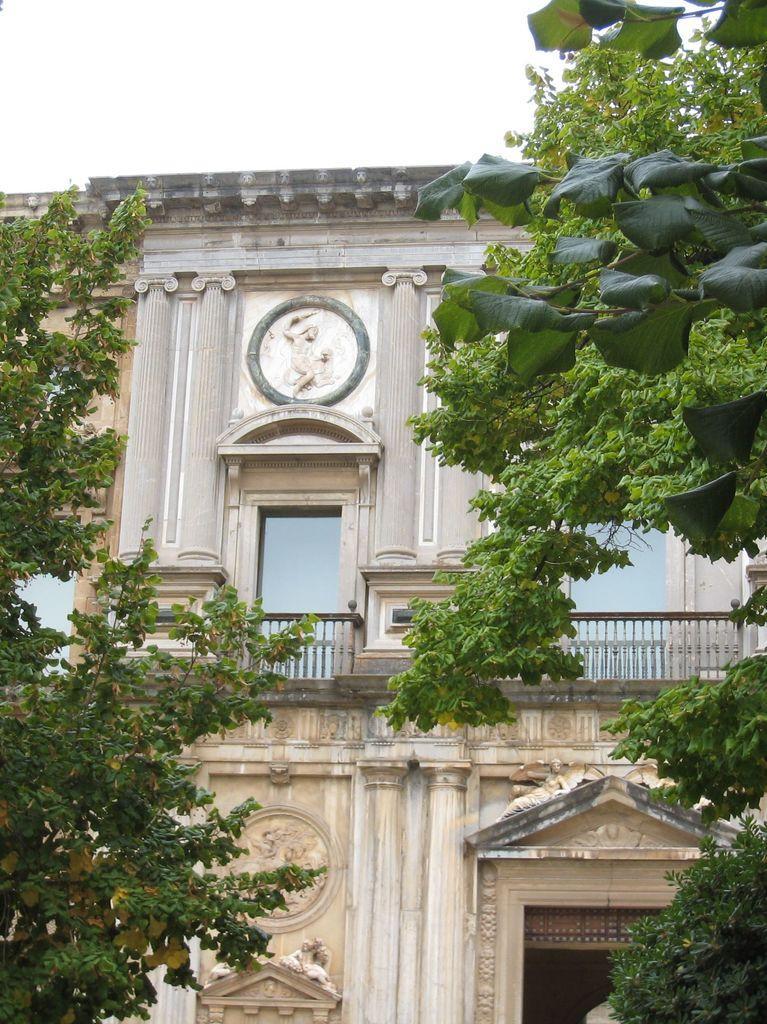Can you describe this image briefly? Building with glass windows and fence. In-front of this building there are trees. 